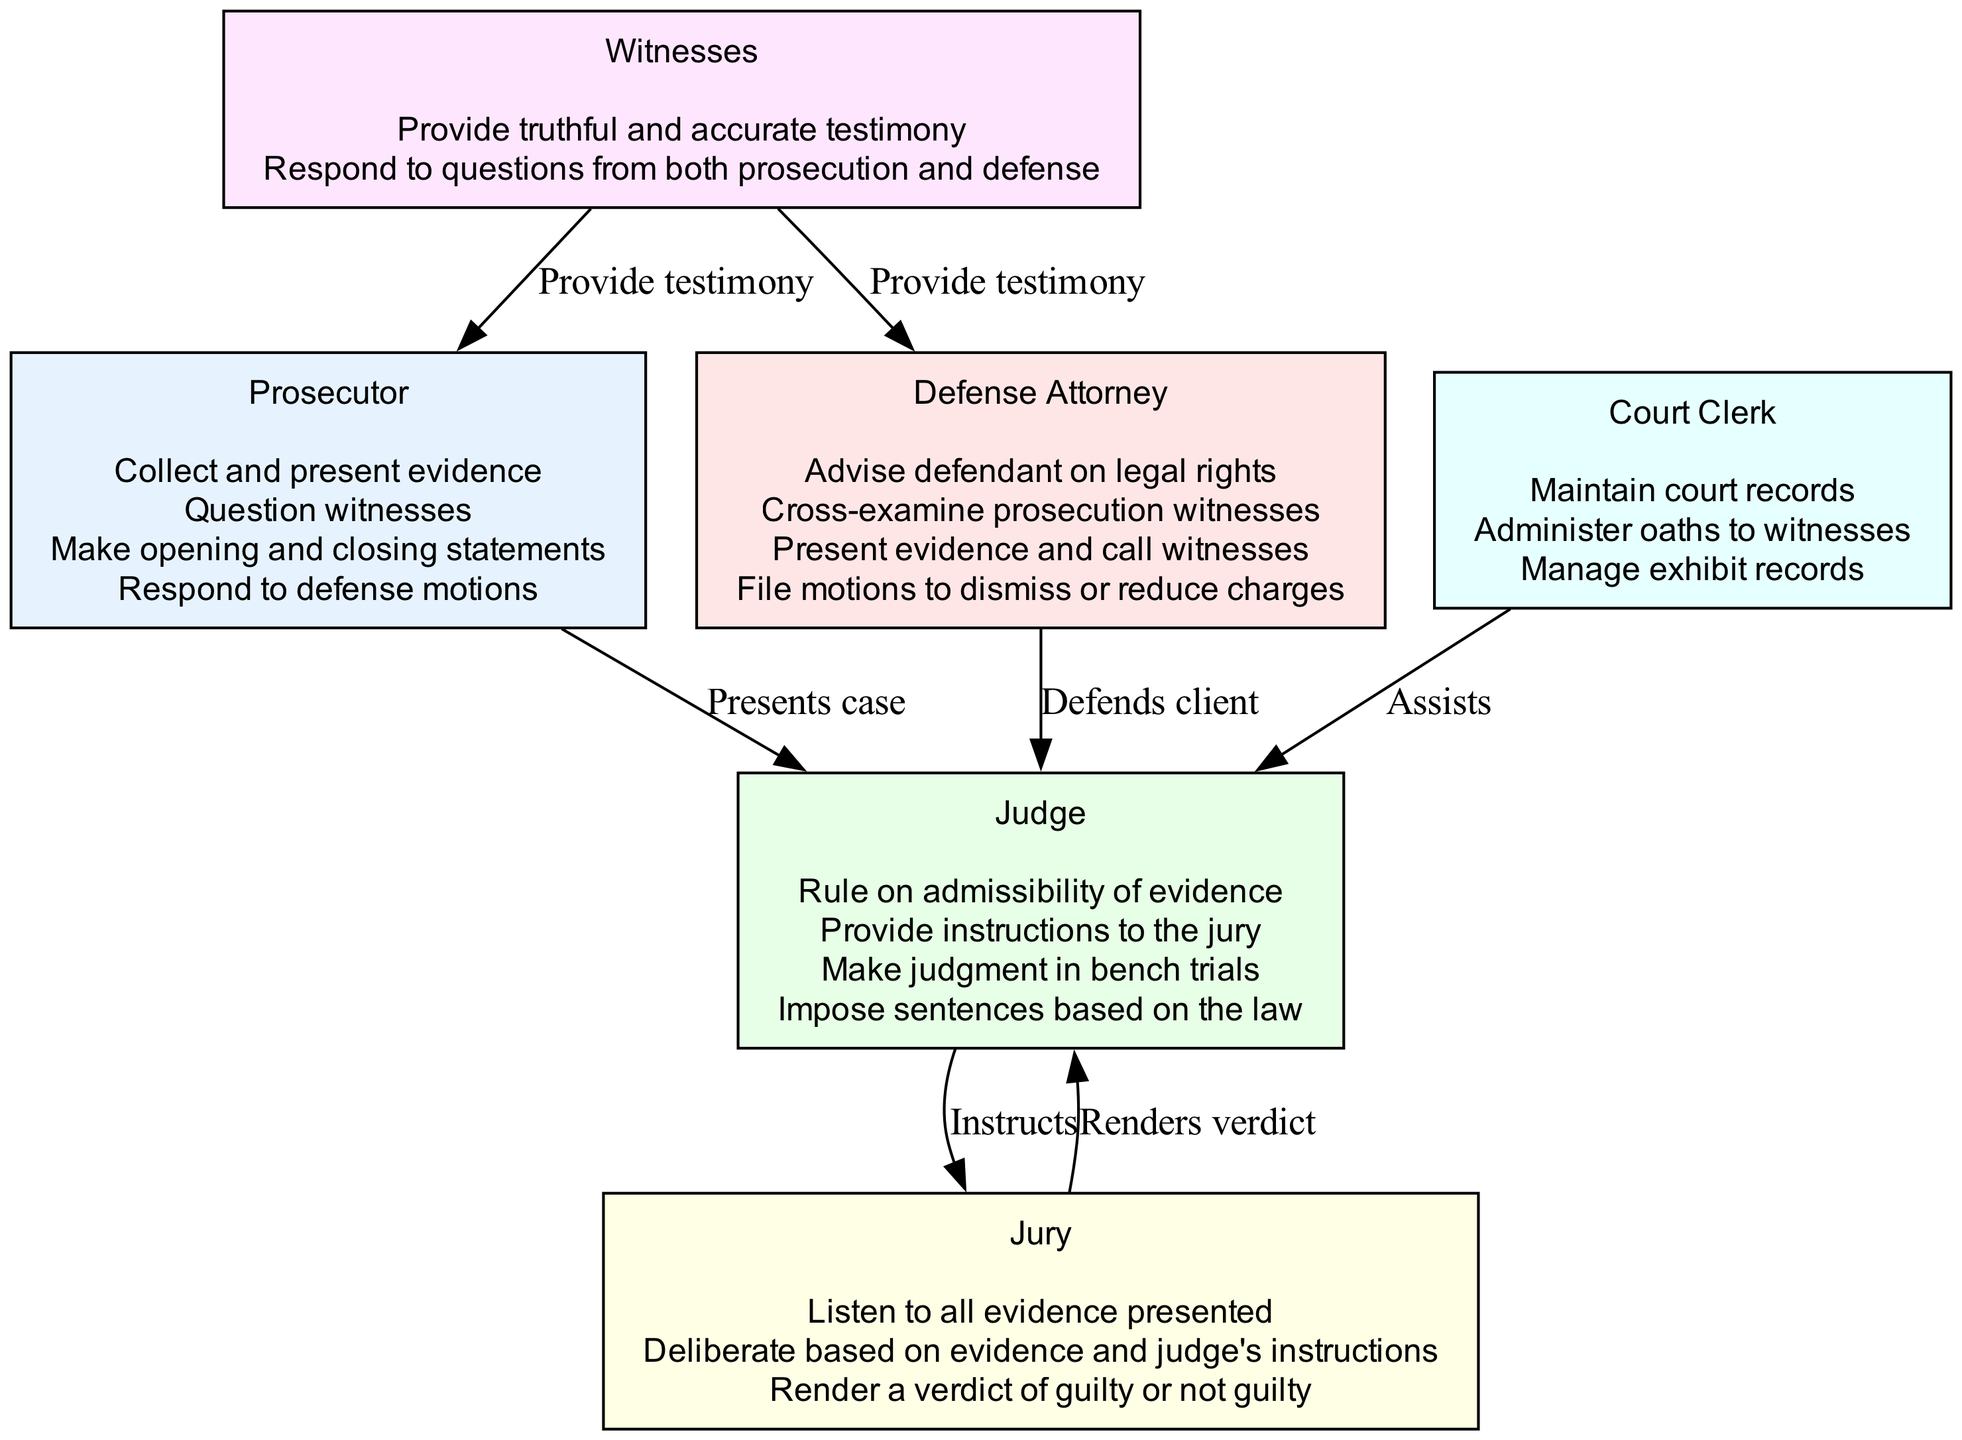What is the primary role of the prosecutor? The diagram identifies the prosecutor as responsible for presenting the case against the defendant. This role is key in ensuring the state’s interests are represented in the legal proceedings.
Answer: Presenting case How many key responsibilities does the defense attorney have? By reviewing the defense attorney's section in the diagram, we see that there are four key responsibilities listed, which are distinct actions they take during legal proceedings.
Answer: Four Who does the judge provide instructions to? Looking at the diagram, the arrows indicate a directional relationship where the judge instructs the jury. This relationship helps ensure the jury understands the law they must apply to the case.
Answer: Jury What do witnesses provide to both the prosecutor and defense attorney? The diagram shows that witnesses are responsible for providing testimony. This testimony is crucial for both sides to build their cases.
Answer: Testimony What is the relationship between the jury and the judge? The diagram indicates a two-way interaction between the jury and the judge, specifically where the jury renders a verdict and the judge instructs them, showing mutual involvement in the trial process.
Answer: Instructs What role does the court clerk serve in relation to the judge? Analyzing the diagram, the court clerk assists the judge according to the edges outlined. This highlights the administrative support role of the court clerk in the legal proceedings.
Answer: Assists How many roles are depicted in the diagram? By counting the listed roles in the diagram, we find six different roles, each represented with distinct responsibilities and interactions within the legal process.
Answer: Six What key responsibility does the jury have during deliberation? The diagram states that the jury’s responsibility during deliberation is to render a verdict based on the evidence presented and the judge’s instructions, showing their role in the final decision-making process.
Answer: Render a verdict What is the main duty of the judge during bench trials? The diagram specifies that the judge makes judgments in bench trials, emphasizing their decisive role in these types of legal proceedings where a jury is not present.
Answer: Make judgment 